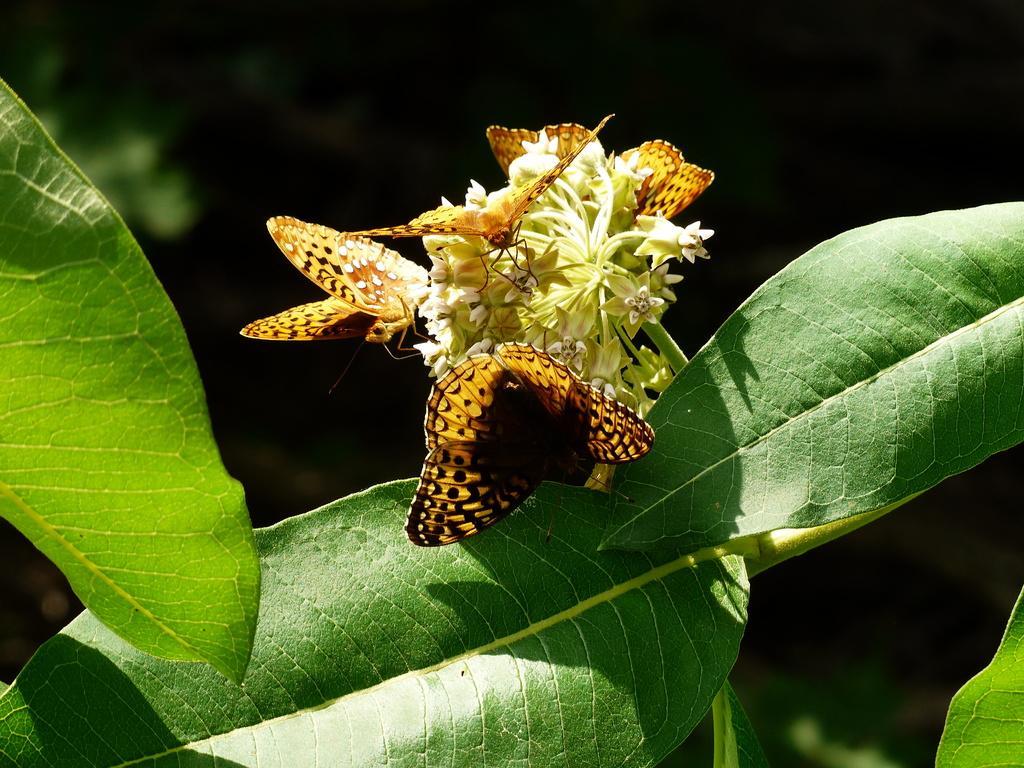Describe this image in one or two sentences. In the given image i can see a few butterflies on the flowers and leaves. 